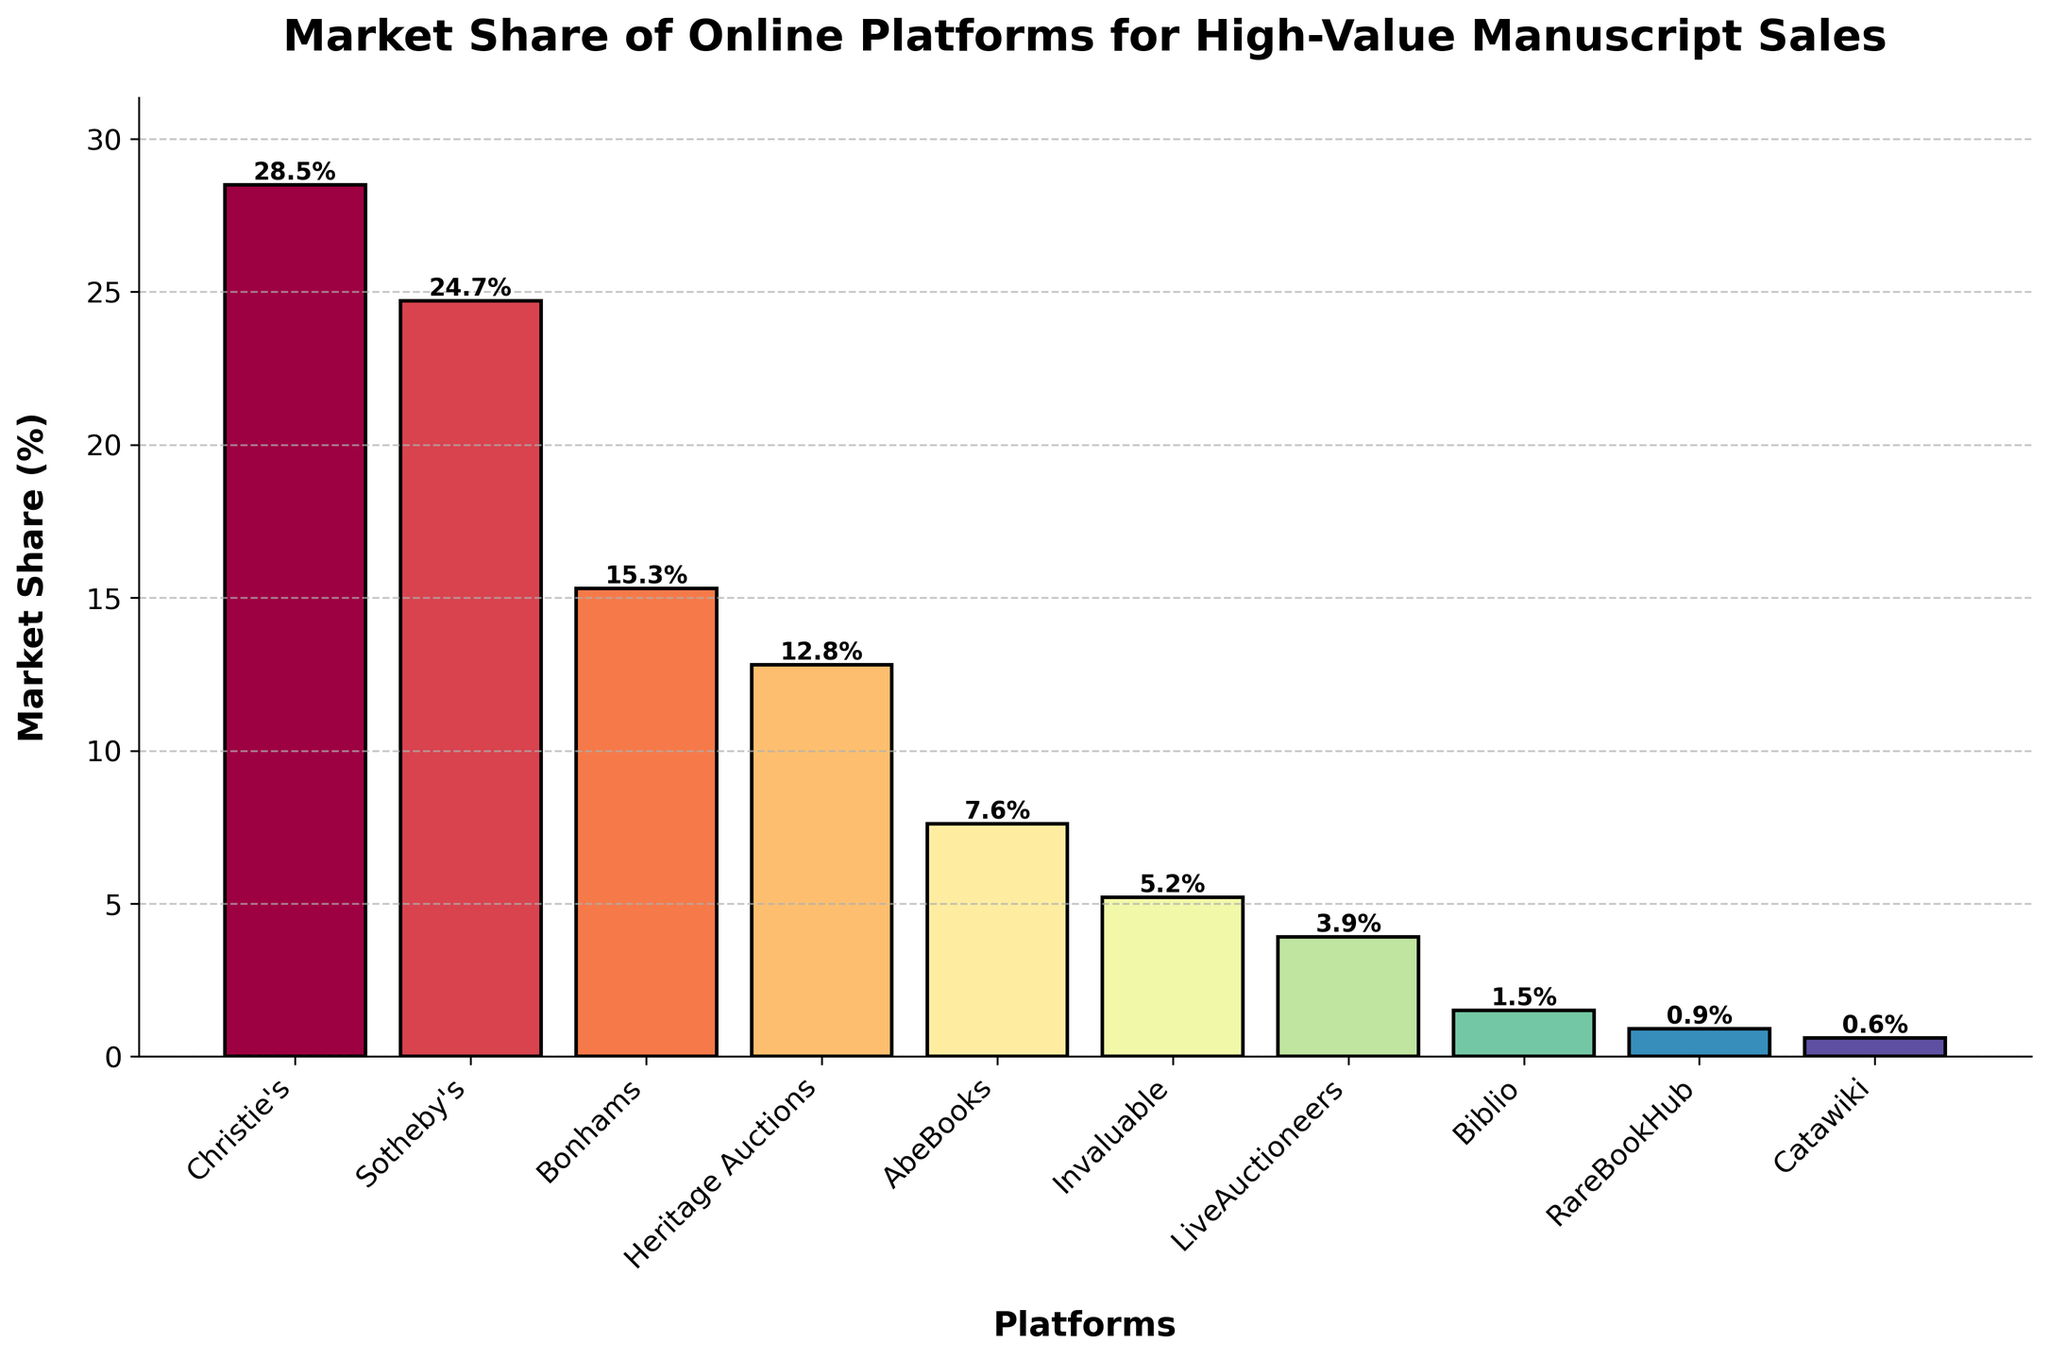What is the platform with the highest market share? Looking at the chart, we identify the highest bar, which represents the platform with the highest market share. It is Christie's with a market share of 28.5%.
Answer: Christie's Which platform has a lower market share, Bonhams or Heritage Auctions? Compare the heights of the bars for Bonhams and Heritage Auctions. Bonhams has a market share of 15.3%, and Heritage Auctions has 12.8%. Since 12.8% is lower than 15.3%, Heritage Auctions has the lower market share.
Answer: Heritage Auctions What's the combined market share of the top three platforms? The top three platforms based on bar heights are Christie's (28.5%), Sotheby's (24.7%), and Bonhams (15.3%). Adding these percentages: 28.5 + 24.7 + 15.3 = 68.5%. So, the combined market share is 68.5%.
Answer: 68.5% Which platform has a market share closest to 10%? Examine the bars to find the one with a market share nearest to 10%. Heritage Auctions at 12.8% is closest.
Answer: Heritage Auctions What's the total market share of platforms with less than 5% market share? Identify platforms with market shares below 5%: LiveAuctioneers (3.9%), Biblio (1.5%), RareBookHub (0.9%), and Catawiki (0.6%). Sum these percentages: 3.9 + 1.5 + 0.9 + 0.6 = 6.9%. The total market share is 6.9%.
Answer: 6.9% By how much does Sotheby's market share exceed AbeBooks'? Find the difference between the market shares of Sotheby's (24.7%) and AbeBooks (7.6%): 24.7 - 7.6 = 17.1%. Sotheby's market share exceeds AbeBooks' by 17.1%.
Answer: 17.1% Which platforms have market shares greater than 10% but less than 20%? Identify the bars with market shares between 10% and 20%. Bonhams (15.3%) and Heritage Auctions (12.8%) fall into this range.
Answer: Bonhams and Heritage Auctions What percentage do Christie's and Sotheby's together hold in the market? Add the market shares of Christie's (28.5%) and Sotheby's (24.7%): 28.5 + 24.7 = 53.2%. Combined, they hold 53.2% of the market.
Answer: 53.2% Which has a higher market share, Bonhams or the combined share of Biblio and RareBookHub? Compare Bonhams' market share (15.3%) with the combined market share of Biblio (1.5%) and RareBookHub (0.9%): 1.5 + 0.9 = 2.4%. 15.3% is greater than 2.4%, so Bonhams has a higher market share.
Answer: Bonhams 